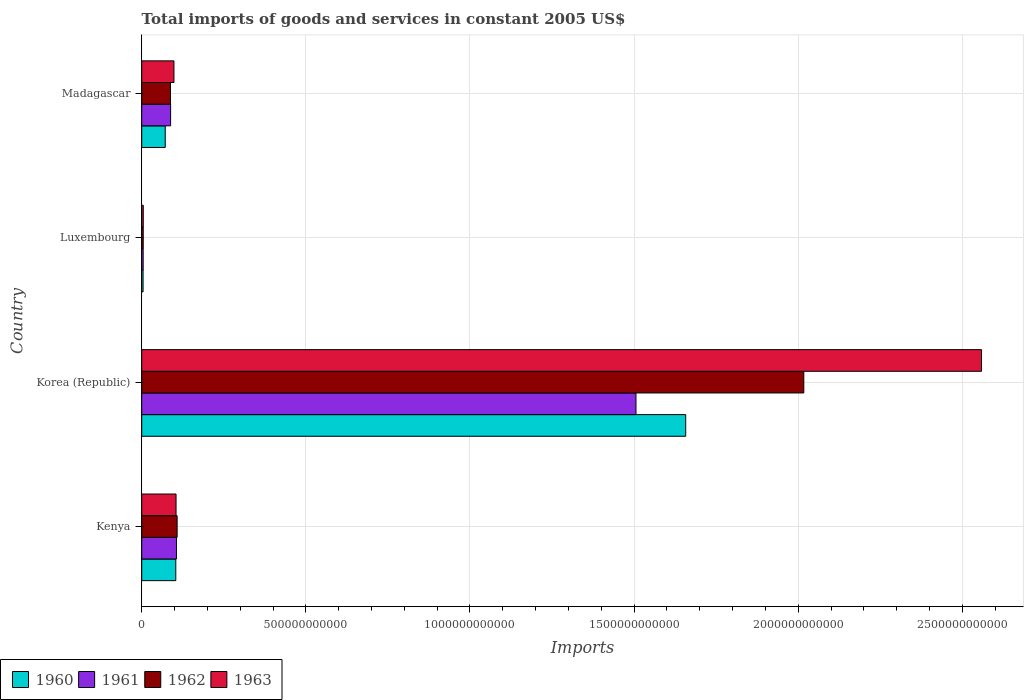How many groups of bars are there?
Ensure brevity in your answer.  4. Are the number of bars per tick equal to the number of legend labels?
Your response must be concise. Yes. How many bars are there on the 1st tick from the bottom?
Offer a very short reply. 4. What is the label of the 2nd group of bars from the top?
Your answer should be very brief. Luxembourg. What is the total imports of goods and services in 1961 in Luxembourg?
Your answer should be compact. 4.41e+09. Across all countries, what is the maximum total imports of goods and services in 1962?
Your answer should be compact. 2.02e+12. Across all countries, what is the minimum total imports of goods and services in 1963?
Provide a succinct answer. 4.69e+09. In which country was the total imports of goods and services in 1961 maximum?
Offer a very short reply. Korea (Republic). In which country was the total imports of goods and services in 1962 minimum?
Make the answer very short. Luxembourg. What is the total total imports of goods and services in 1960 in the graph?
Make the answer very short. 1.84e+12. What is the difference between the total imports of goods and services in 1960 in Kenya and that in Korea (Republic)?
Your answer should be compact. -1.55e+12. What is the difference between the total imports of goods and services in 1960 in Luxembourg and the total imports of goods and services in 1961 in Madagascar?
Ensure brevity in your answer.  -8.39e+1. What is the average total imports of goods and services in 1961 per country?
Offer a terse response. 4.26e+11. What is the difference between the total imports of goods and services in 1962 and total imports of goods and services in 1960 in Korea (Republic)?
Provide a short and direct response. 3.60e+11. In how many countries, is the total imports of goods and services in 1961 greater than 1200000000000 US$?
Your answer should be very brief. 1. What is the ratio of the total imports of goods and services in 1961 in Kenya to that in Korea (Republic)?
Offer a terse response. 0.07. Is the difference between the total imports of goods and services in 1962 in Kenya and Korea (Republic) greater than the difference between the total imports of goods and services in 1960 in Kenya and Korea (Republic)?
Offer a terse response. No. What is the difference between the highest and the second highest total imports of goods and services in 1961?
Offer a terse response. 1.40e+12. What is the difference between the highest and the lowest total imports of goods and services in 1962?
Give a very brief answer. 2.01e+12. In how many countries, is the total imports of goods and services in 1960 greater than the average total imports of goods and services in 1960 taken over all countries?
Your answer should be compact. 1. Is the sum of the total imports of goods and services in 1962 in Luxembourg and Madagascar greater than the maximum total imports of goods and services in 1963 across all countries?
Offer a very short reply. No. What does the 3rd bar from the bottom in Madagascar represents?
Provide a short and direct response. 1962. How many bars are there?
Give a very brief answer. 16. What is the difference between two consecutive major ticks on the X-axis?
Give a very brief answer. 5.00e+11. How many legend labels are there?
Give a very brief answer. 4. How are the legend labels stacked?
Provide a succinct answer. Horizontal. What is the title of the graph?
Ensure brevity in your answer.  Total imports of goods and services in constant 2005 US$. Does "1976" appear as one of the legend labels in the graph?
Your answer should be compact. No. What is the label or title of the X-axis?
Give a very brief answer. Imports. What is the Imports in 1960 in Kenya?
Make the answer very short. 1.04e+11. What is the Imports in 1961 in Kenya?
Provide a succinct answer. 1.06e+11. What is the Imports in 1962 in Kenya?
Make the answer very short. 1.08e+11. What is the Imports of 1963 in Kenya?
Give a very brief answer. 1.05e+11. What is the Imports of 1960 in Korea (Republic)?
Your answer should be compact. 1.66e+12. What is the Imports of 1961 in Korea (Republic)?
Keep it short and to the point. 1.51e+12. What is the Imports in 1962 in Korea (Republic)?
Provide a short and direct response. 2.02e+12. What is the Imports of 1963 in Korea (Republic)?
Make the answer very short. 2.56e+12. What is the Imports in 1960 in Luxembourg?
Ensure brevity in your answer.  4.11e+09. What is the Imports in 1961 in Luxembourg?
Provide a succinct answer. 4.41e+09. What is the Imports in 1962 in Luxembourg?
Give a very brief answer. 4.55e+09. What is the Imports of 1963 in Luxembourg?
Give a very brief answer. 4.69e+09. What is the Imports of 1960 in Madagascar?
Provide a short and direct response. 7.16e+1. What is the Imports in 1961 in Madagascar?
Ensure brevity in your answer.  8.80e+1. What is the Imports of 1962 in Madagascar?
Provide a succinct answer. 8.76e+1. What is the Imports in 1963 in Madagascar?
Offer a terse response. 9.82e+1. Across all countries, what is the maximum Imports in 1960?
Offer a terse response. 1.66e+12. Across all countries, what is the maximum Imports of 1961?
Give a very brief answer. 1.51e+12. Across all countries, what is the maximum Imports of 1962?
Your response must be concise. 2.02e+12. Across all countries, what is the maximum Imports in 1963?
Your answer should be compact. 2.56e+12. Across all countries, what is the minimum Imports of 1960?
Offer a terse response. 4.11e+09. Across all countries, what is the minimum Imports of 1961?
Offer a very short reply. 4.41e+09. Across all countries, what is the minimum Imports of 1962?
Provide a succinct answer. 4.55e+09. Across all countries, what is the minimum Imports of 1963?
Your answer should be compact. 4.69e+09. What is the total Imports in 1960 in the graph?
Give a very brief answer. 1.84e+12. What is the total Imports of 1961 in the graph?
Give a very brief answer. 1.70e+12. What is the total Imports in 1962 in the graph?
Offer a very short reply. 2.22e+12. What is the total Imports in 1963 in the graph?
Your response must be concise. 2.77e+12. What is the difference between the Imports in 1960 in Kenya and that in Korea (Republic)?
Your answer should be very brief. -1.55e+12. What is the difference between the Imports in 1961 in Kenya and that in Korea (Republic)?
Keep it short and to the point. -1.40e+12. What is the difference between the Imports of 1962 in Kenya and that in Korea (Republic)?
Your response must be concise. -1.91e+12. What is the difference between the Imports in 1963 in Kenya and that in Korea (Republic)?
Provide a succinct answer. -2.45e+12. What is the difference between the Imports in 1960 in Kenya and that in Luxembourg?
Make the answer very short. 9.97e+1. What is the difference between the Imports in 1961 in Kenya and that in Luxembourg?
Your answer should be compact. 1.01e+11. What is the difference between the Imports in 1962 in Kenya and that in Luxembourg?
Provide a short and direct response. 1.03e+11. What is the difference between the Imports of 1963 in Kenya and that in Luxembourg?
Your answer should be compact. 9.99e+1. What is the difference between the Imports in 1960 in Kenya and that in Madagascar?
Keep it short and to the point. 3.22e+1. What is the difference between the Imports in 1961 in Kenya and that in Madagascar?
Provide a succinct answer. 1.78e+1. What is the difference between the Imports of 1962 in Kenya and that in Madagascar?
Ensure brevity in your answer.  2.03e+1. What is the difference between the Imports of 1963 in Kenya and that in Madagascar?
Your answer should be very brief. 6.40e+09. What is the difference between the Imports of 1960 in Korea (Republic) and that in Luxembourg?
Provide a short and direct response. 1.65e+12. What is the difference between the Imports of 1961 in Korea (Republic) and that in Luxembourg?
Give a very brief answer. 1.50e+12. What is the difference between the Imports of 1962 in Korea (Republic) and that in Luxembourg?
Keep it short and to the point. 2.01e+12. What is the difference between the Imports in 1963 in Korea (Republic) and that in Luxembourg?
Provide a succinct answer. 2.55e+12. What is the difference between the Imports of 1960 in Korea (Republic) and that in Madagascar?
Provide a succinct answer. 1.59e+12. What is the difference between the Imports of 1961 in Korea (Republic) and that in Madagascar?
Provide a short and direct response. 1.42e+12. What is the difference between the Imports in 1962 in Korea (Republic) and that in Madagascar?
Offer a terse response. 1.93e+12. What is the difference between the Imports of 1963 in Korea (Republic) and that in Madagascar?
Keep it short and to the point. 2.46e+12. What is the difference between the Imports of 1960 in Luxembourg and that in Madagascar?
Provide a succinct answer. -6.75e+1. What is the difference between the Imports in 1961 in Luxembourg and that in Madagascar?
Ensure brevity in your answer.  -8.36e+1. What is the difference between the Imports of 1962 in Luxembourg and that in Madagascar?
Your answer should be compact. -8.31e+1. What is the difference between the Imports in 1963 in Luxembourg and that in Madagascar?
Offer a terse response. -9.35e+1. What is the difference between the Imports in 1960 in Kenya and the Imports in 1961 in Korea (Republic)?
Keep it short and to the point. -1.40e+12. What is the difference between the Imports in 1960 in Kenya and the Imports in 1962 in Korea (Republic)?
Provide a short and direct response. -1.91e+12. What is the difference between the Imports of 1960 in Kenya and the Imports of 1963 in Korea (Republic)?
Provide a short and direct response. -2.45e+12. What is the difference between the Imports of 1961 in Kenya and the Imports of 1962 in Korea (Republic)?
Provide a succinct answer. -1.91e+12. What is the difference between the Imports in 1961 in Kenya and the Imports in 1963 in Korea (Republic)?
Offer a terse response. -2.45e+12. What is the difference between the Imports in 1962 in Kenya and the Imports in 1963 in Korea (Republic)?
Provide a succinct answer. -2.45e+12. What is the difference between the Imports of 1960 in Kenya and the Imports of 1961 in Luxembourg?
Offer a very short reply. 9.94e+1. What is the difference between the Imports of 1960 in Kenya and the Imports of 1962 in Luxembourg?
Provide a succinct answer. 9.93e+1. What is the difference between the Imports of 1960 in Kenya and the Imports of 1963 in Luxembourg?
Ensure brevity in your answer.  9.91e+1. What is the difference between the Imports in 1961 in Kenya and the Imports in 1962 in Luxembourg?
Offer a very short reply. 1.01e+11. What is the difference between the Imports of 1961 in Kenya and the Imports of 1963 in Luxembourg?
Provide a short and direct response. 1.01e+11. What is the difference between the Imports of 1962 in Kenya and the Imports of 1963 in Luxembourg?
Keep it short and to the point. 1.03e+11. What is the difference between the Imports of 1960 in Kenya and the Imports of 1961 in Madagascar?
Your response must be concise. 1.58e+1. What is the difference between the Imports in 1960 in Kenya and the Imports in 1962 in Madagascar?
Make the answer very short. 1.62e+1. What is the difference between the Imports of 1960 in Kenya and the Imports of 1963 in Madagascar?
Ensure brevity in your answer.  5.64e+09. What is the difference between the Imports of 1961 in Kenya and the Imports of 1962 in Madagascar?
Provide a succinct answer. 1.82e+1. What is the difference between the Imports of 1961 in Kenya and the Imports of 1963 in Madagascar?
Provide a succinct answer. 7.66e+09. What is the difference between the Imports in 1962 in Kenya and the Imports in 1963 in Madagascar?
Provide a succinct answer. 9.68e+09. What is the difference between the Imports of 1960 in Korea (Republic) and the Imports of 1961 in Luxembourg?
Provide a short and direct response. 1.65e+12. What is the difference between the Imports of 1960 in Korea (Republic) and the Imports of 1962 in Luxembourg?
Your answer should be compact. 1.65e+12. What is the difference between the Imports of 1960 in Korea (Republic) and the Imports of 1963 in Luxembourg?
Provide a succinct answer. 1.65e+12. What is the difference between the Imports in 1961 in Korea (Republic) and the Imports in 1962 in Luxembourg?
Your answer should be very brief. 1.50e+12. What is the difference between the Imports of 1961 in Korea (Republic) and the Imports of 1963 in Luxembourg?
Provide a succinct answer. 1.50e+12. What is the difference between the Imports of 1962 in Korea (Republic) and the Imports of 1963 in Luxembourg?
Make the answer very short. 2.01e+12. What is the difference between the Imports in 1960 in Korea (Republic) and the Imports in 1961 in Madagascar?
Keep it short and to the point. 1.57e+12. What is the difference between the Imports in 1960 in Korea (Republic) and the Imports in 1962 in Madagascar?
Provide a succinct answer. 1.57e+12. What is the difference between the Imports of 1960 in Korea (Republic) and the Imports of 1963 in Madagascar?
Keep it short and to the point. 1.56e+12. What is the difference between the Imports of 1961 in Korea (Republic) and the Imports of 1962 in Madagascar?
Your answer should be compact. 1.42e+12. What is the difference between the Imports in 1961 in Korea (Republic) and the Imports in 1963 in Madagascar?
Your answer should be very brief. 1.41e+12. What is the difference between the Imports in 1962 in Korea (Republic) and the Imports in 1963 in Madagascar?
Provide a short and direct response. 1.92e+12. What is the difference between the Imports of 1960 in Luxembourg and the Imports of 1961 in Madagascar?
Provide a short and direct response. -8.39e+1. What is the difference between the Imports of 1960 in Luxembourg and the Imports of 1962 in Madagascar?
Offer a very short reply. -8.35e+1. What is the difference between the Imports in 1960 in Luxembourg and the Imports in 1963 in Madagascar?
Offer a very short reply. -9.41e+1. What is the difference between the Imports in 1961 in Luxembourg and the Imports in 1962 in Madagascar?
Ensure brevity in your answer.  -8.32e+1. What is the difference between the Imports in 1961 in Luxembourg and the Imports in 1963 in Madagascar?
Provide a succinct answer. -9.38e+1. What is the difference between the Imports in 1962 in Luxembourg and the Imports in 1963 in Madagascar?
Ensure brevity in your answer.  -9.36e+1. What is the average Imports of 1960 per country?
Your response must be concise. 4.59e+11. What is the average Imports in 1961 per country?
Make the answer very short. 4.26e+11. What is the average Imports in 1962 per country?
Make the answer very short. 5.54e+11. What is the average Imports of 1963 per country?
Your answer should be very brief. 6.91e+11. What is the difference between the Imports of 1960 and Imports of 1961 in Kenya?
Provide a short and direct response. -2.02e+09. What is the difference between the Imports in 1960 and Imports in 1962 in Kenya?
Keep it short and to the point. -4.04e+09. What is the difference between the Imports in 1960 and Imports in 1963 in Kenya?
Keep it short and to the point. -7.65e+08. What is the difference between the Imports in 1961 and Imports in 1962 in Kenya?
Your answer should be compact. -2.02e+09. What is the difference between the Imports in 1961 and Imports in 1963 in Kenya?
Provide a succinct answer. 1.26e+09. What is the difference between the Imports in 1962 and Imports in 1963 in Kenya?
Keep it short and to the point. 3.27e+09. What is the difference between the Imports of 1960 and Imports of 1961 in Korea (Republic)?
Provide a short and direct response. 1.51e+11. What is the difference between the Imports in 1960 and Imports in 1962 in Korea (Republic)?
Your answer should be very brief. -3.60e+11. What is the difference between the Imports of 1960 and Imports of 1963 in Korea (Republic)?
Give a very brief answer. -9.01e+11. What is the difference between the Imports of 1961 and Imports of 1962 in Korea (Republic)?
Keep it short and to the point. -5.11e+11. What is the difference between the Imports of 1961 and Imports of 1963 in Korea (Republic)?
Make the answer very short. -1.05e+12. What is the difference between the Imports in 1962 and Imports in 1963 in Korea (Republic)?
Give a very brief answer. -5.41e+11. What is the difference between the Imports in 1960 and Imports in 1961 in Luxembourg?
Provide a succinct answer. -3.01e+08. What is the difference between the Imports of 1960 and Imports of 1962 in Luxembourg?
Provide a short and direct response. -4.41e+08. What is the difference between the Imports in 1960 and Imports in 1963 in Luxembourg?
Provide a short and direct response. -5.83e+08. What is the difference between the Imports of 1961 and Imports of 1962 in Luxembourg?
Keep it short and to the point. -1.40e+08. What is the difference between the Imports of 1961 and Imports of 1963 in Luxembourg?
Provide a succinct answer. -2.82e+08. What is the difference between the Imports of 1962 and Imports of 1963 in Luxembourg?
Keep it short and to the point. -1.42e+08. What is the difference between the Imports of 1960 and Imports of 1961 in Madagascar?
Ensure brevity in your answer.  -1.64e+1. What is the difference between the Imports in 1960 and Imports in 1962 in Madagascar?
Your answer should be very brief. -1.60e+1. What is the difference between the Imports in 1960 and Imports in 1963 in Madagascar?
Ensure brevity in your answer.  -2.65e+1. What is the difference between the Imports in 1961 and Imports in 1962 in Madagascar?
Provide a succinct answer. 3.99e+08. What is the difference between the Imports of 1961 and Imports of 1963 in Madagascar?
Make the answer very short. -1.02e+1. What is the difference between the Imports in 1962 and Imports in 1963 in Madagascar?
Provide a succinct answer. -1.06e+1. What is the ratio of the Imports of 1960 in Kenya to that in Korea (Republic)?
Offer a very short reply. 0.06. What is the ratio of the Imports in 1961 in Kenya to that in Korea (Republic)?
Offer a very short reply. 0.07. What is the ratio of the Imports of 1962 in Kenya to that in Korea (Republic)?
Provide a succinct answer. 0.05. What is the ratio of the Imports of 1963 in Kenya to that in Korea (Republic)?
Your answer should be very brief. 0.04. What is the ratio of the Imports of 1960 in Kenya to that in Luxembourg?
Provide a succinct answer. 25.27. What is the ratio of the Imports of 1961 in Kenya to that in Luxembourg?
Your answer should be compact. 24. What is the ratio of the Imports of 1962 in Kenya to that in Luxembourg?
Provide a short and direct response. 23.7. What is the ratio of the Imports of 1963 in Kenya to that in Luxembourg?
Provide a succinct answer. 22.29. What is the ratio of the Imports in 1960 in Kenya to that in Madagascar?
Ensure brevity in your answer.  1.45. What is the ratio of the Imports in 1961 in Kenya to that in Madagascar?
Your answer should be compact. 1.2. What is the ratio of the Imports in 1962 in Kenya to that in Madagascar?
Make the answer very short. 1.23. What is the ratio of the Imports in 1963 in Kenya to that in Madagascar?
Give a very brief answer. 1.07. What is the ratio of the Imports in 1960 in Korea (Republic) to that in Luxembourg?
Offer a terse response. 403.32. What is the ratio of the Imports of 1961 in Korea (Republic) to that in Luxembourg?
Your response must be concise. 341.41. What is the ratio of the Imports in 1962 in Korea (Republic) to that in Luxembourg?
Give a very brief answer. 443.27. What is the ratio of the Imports of 1963 in Korea (Republic) to that in Luxembourg?
Offer a very short reply. 545.22. What is the ratio of the Imports of 1960 in Korea (Republic) to that in Madagascar?
Make the answer very short. 23.13. What is the ratio of the Imports of 1961 in Korea (Republic) to that in Madagascar?
Ensure brevity in your answer.  17.11. What is the ratio of the Imports of 1962 in Korea (Republic) to that in Madagascar?
Your answer should be compact. 23.02. What is the ratio of the Imports in 1963 in Korea (Republic) to that in Madagascar?
Make the answer very short. 26.06. What is the ratio of the Imports in 1960 in Luxembourg to that in Madagascar?
Your answer should be compact. 0.06. What is the ratio of the Imports of 1961 in Luxembourg to that in Madagascar?
Provide a succinct answer. 0.05. What is the ratio of the Imports of 1962 in Luxembourg to that in Madagascar?
Provide a succinct answer. 0.05. What is the ratio of the Imports in 1963 in Luxembourg to that in Madagascar?
Provide a short and direct response. 0.05. What is the difference between the highest and the second highest Imports in 1960?
Offer a very short reply. 1.55e+12. What is the difference between the highest and the second highest Imports in 1961?
Give a very brief answer. 1.40e+12. What is the difference between the highest and the second highest Imports of 1962?
Provide a succinct answer. 1.91e+12. What is the difference between the highest and the second highest Imports of 1963?
Offer a very short reply. 2.45e+12. What is the difference between the highest and the lowest Imports of 1960?
Your answer should be compact. 1.65e+12. What is the difference between the highest and the lowest Imports of 1961?
Ensure brevity in your answer.  1.50e+12. What is the difference between the highest and the lowest Imports of 1962?
Your response must be concise. 2.01e+12. What is the difference between the highest and the lowest Imports of 1963?
Ensure brevity in your answer.  2.55e+12. 